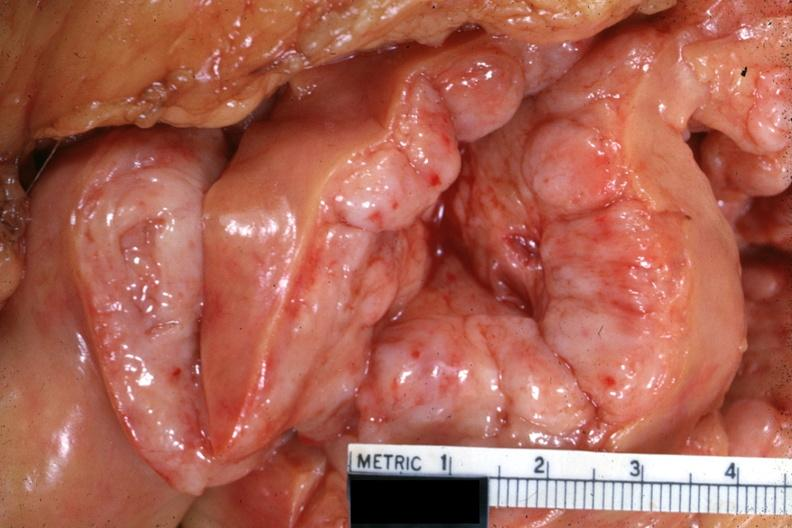what is present?
Answer the question using a single word or phrase. Lymph node 